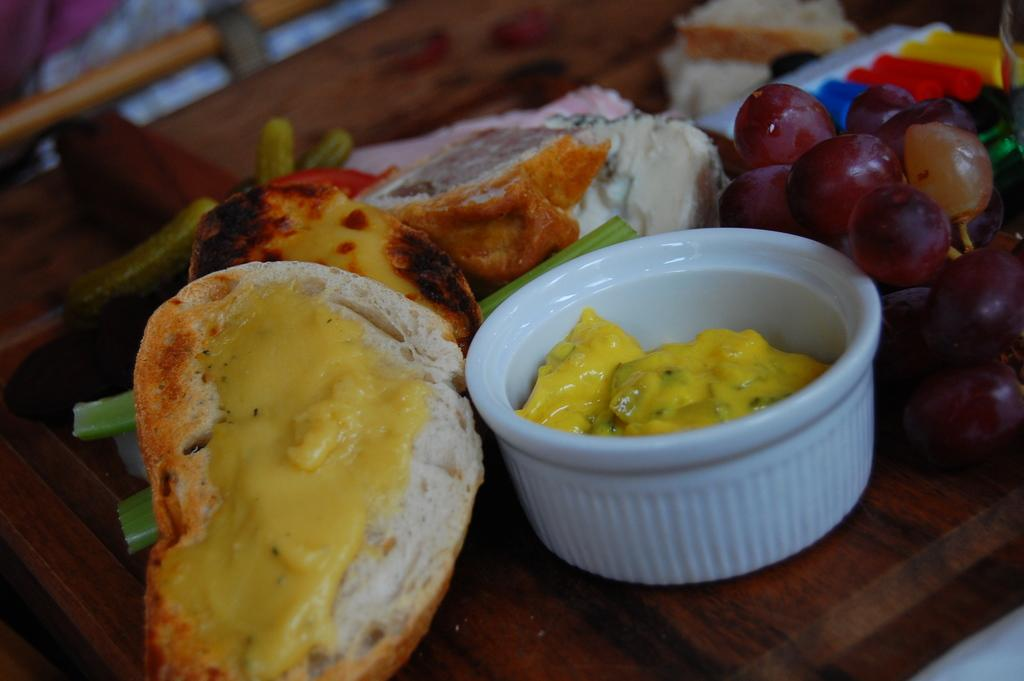What is the main food item in the foreground of the image? There is a bread with cream in the foreground of the image. What other food items can be seen in the foreground? There are grapes and a spring onion in the foreground of the image. What type of container is present in the foreground? There is a white bowl in the foreground of the image. What is the surface on which the cake is placed? The cake is on a wooden surface in the foreground of the image. Are there any other objects in the foreground besides the mentioned items? Yes, there are other unspecified objects in the foreground of the image. What type of frame is surrounding the bread in the image? There is no frame surrounding the bread in the image; it is on a flat surface. 